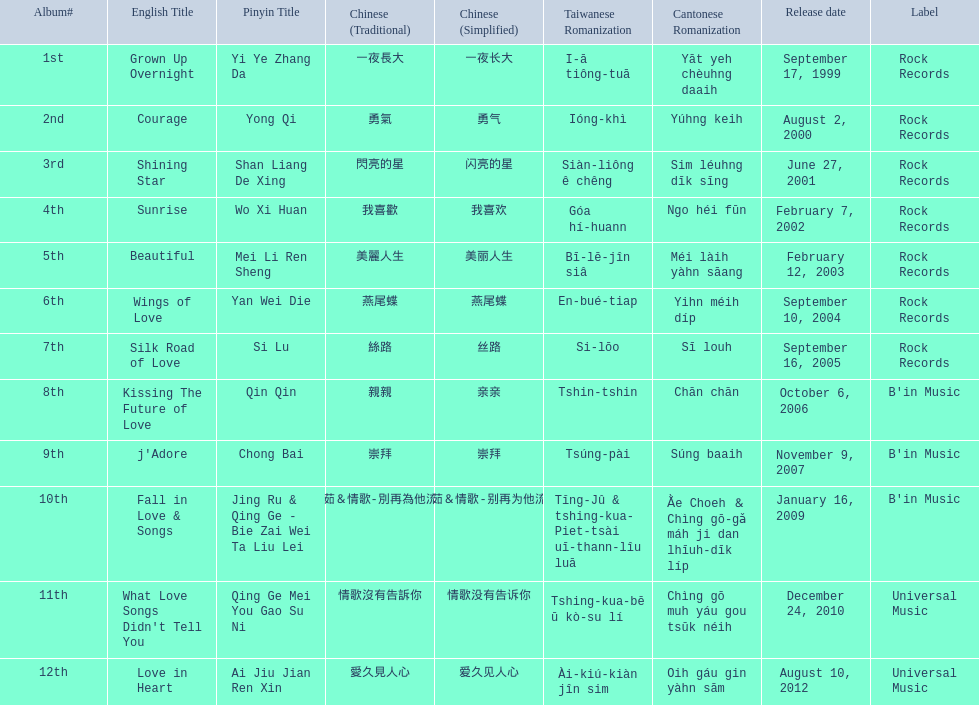Which english titles were released during even years? Courage, Sunrise, Silk Road of Love, Kissing The Future of Love, What Love Songs Didn't Tell You, Love in Heart. Out of the following, which one was released under b's in music? Kissing The Future of Love. 